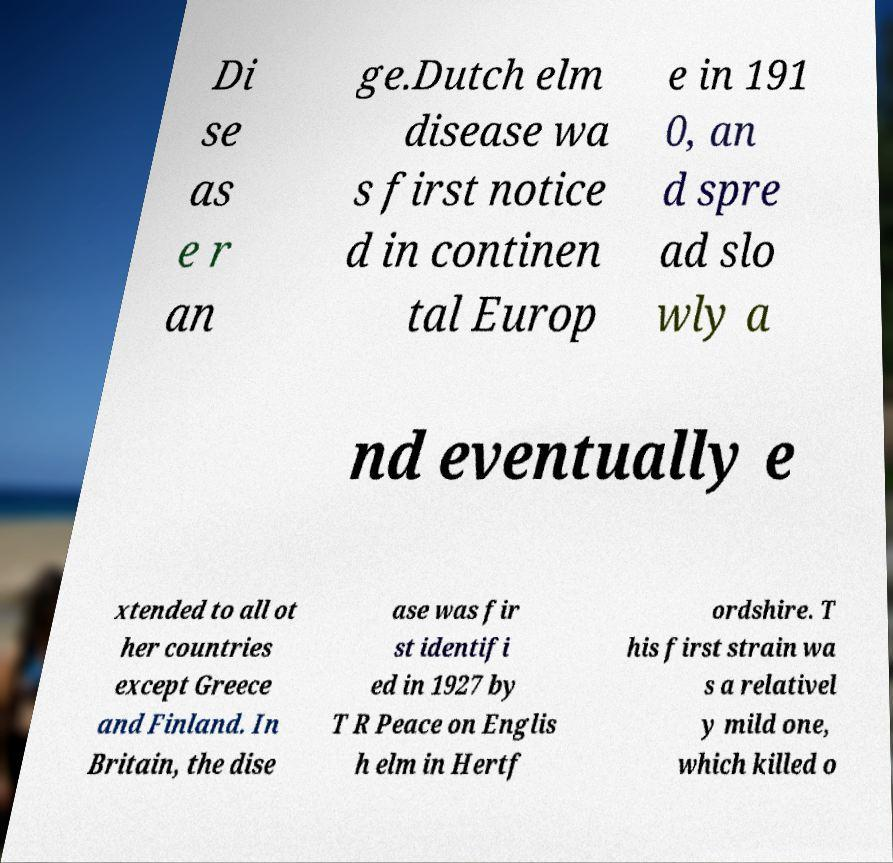Can you read and provide the text displayed in the image?This photo seems to have some interesting text. Can you extract and type it out for me? Di se as e r an ge.Dutch elm disease wa s first notice d in continen tal Europ e in 191 0, an d spre ad slo wly a nd eventually e xtended to all ot her countries except Greece and Finland. In Britain, the dise ase was fir st identifi ed in 1927 by T R Peace on Englis h elm in Hertf ordshire. T his first strain wa s a relativel y mild one, which killed o 